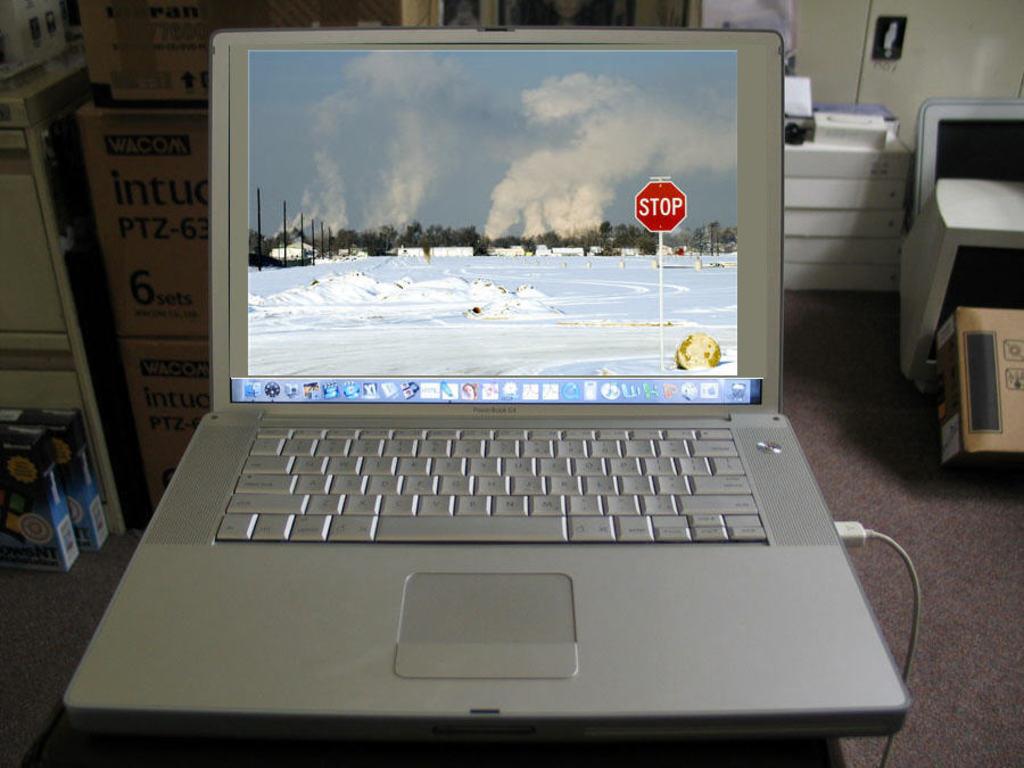What kind of sign is it?
Offer a very short reply. Stop. 